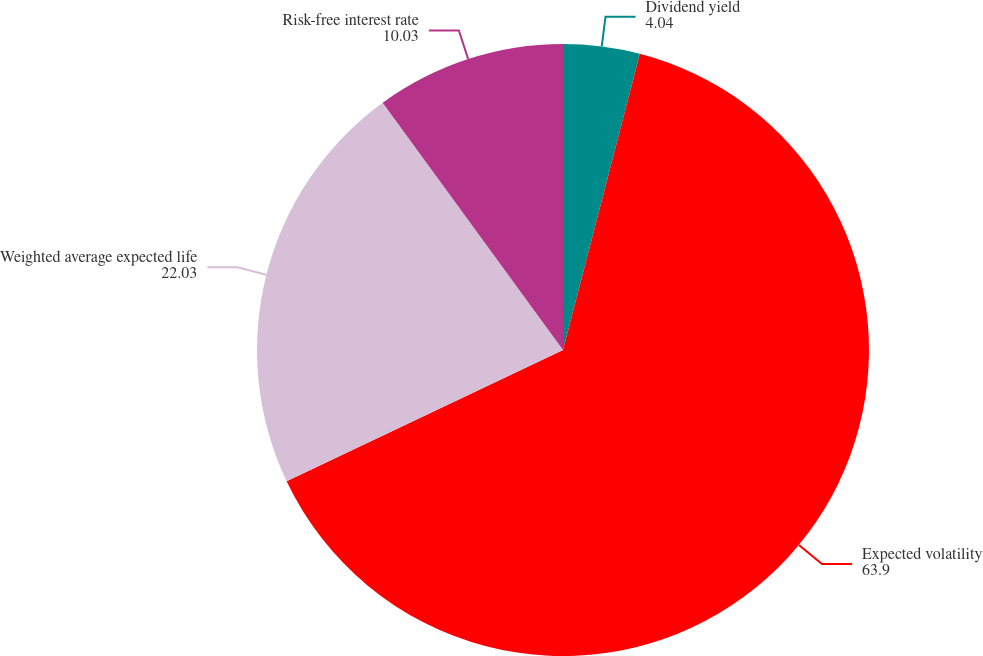Convert chart. <chart><loc_0><loc_0><loc_500><loc_500><pie_chart><fcel>Dividend yield<fcel>Expected volatility<fcel>Weighted average expected life<fcel>Risk-free interest rate<nl><fcel>4.04%<fcel>63.9%<fcel>22.03%<fcel>10.03%<nl></chart> 